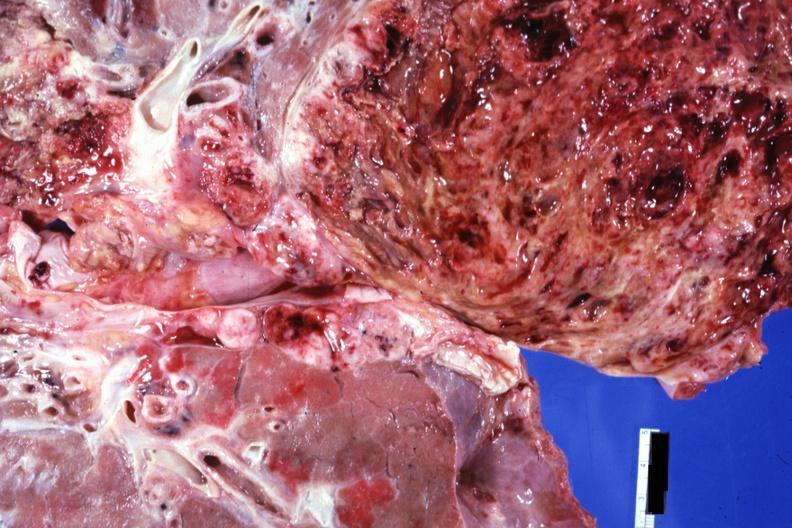what does this image show?
Answer the question using a single word or phrase. Rather close-up view of tumor cut surface 